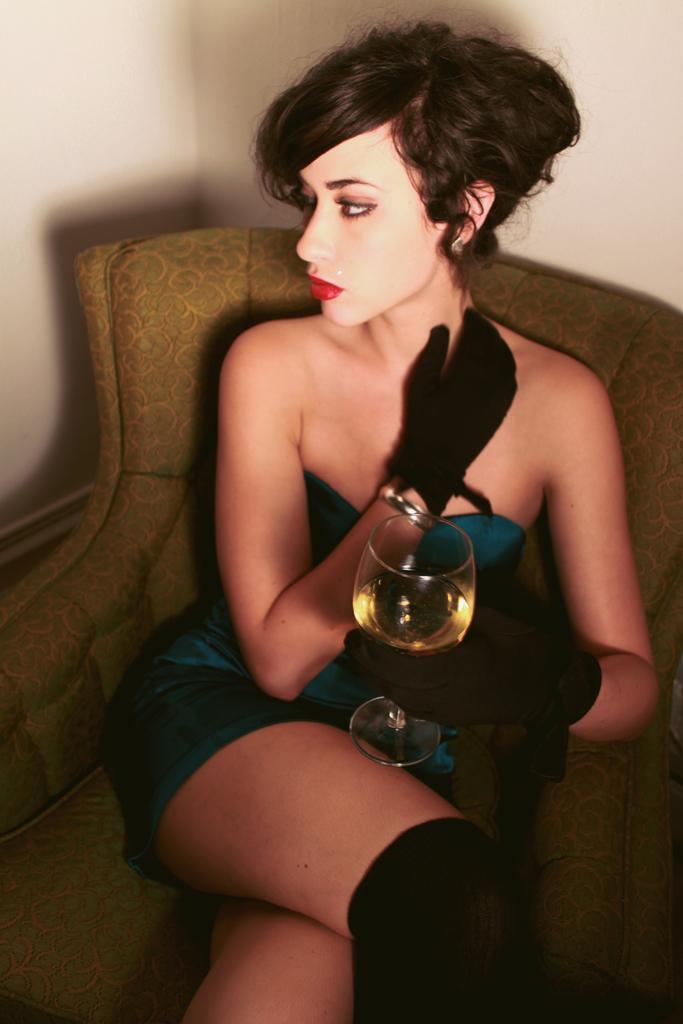How would you summarize this image in a sentence or two? In this picture I can see a woman sitting on the chair and she is holding glass in her hand and I can see a wall in the background. 